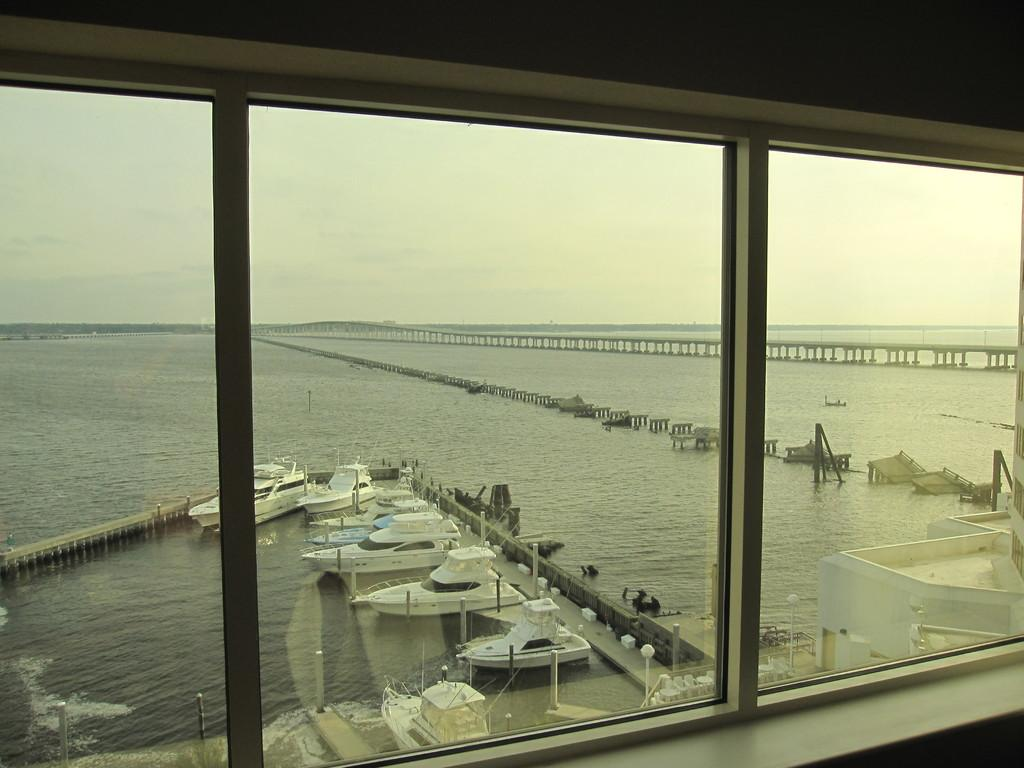What is present in the image that provides a view of the outdoors? There is a window in the image that provides a view of the outdoors. What can be seen through the window in the image? Boats are visible on water through the window. What is visible in the background of the image? The sky is visible in the background of the image. Where is the scarecrow located in the image? There is no scarecrow present in the image. What type of clover can be seen growing near the boats in the image? There is no clover visible in the image; only boats on water can be seen through the window. 